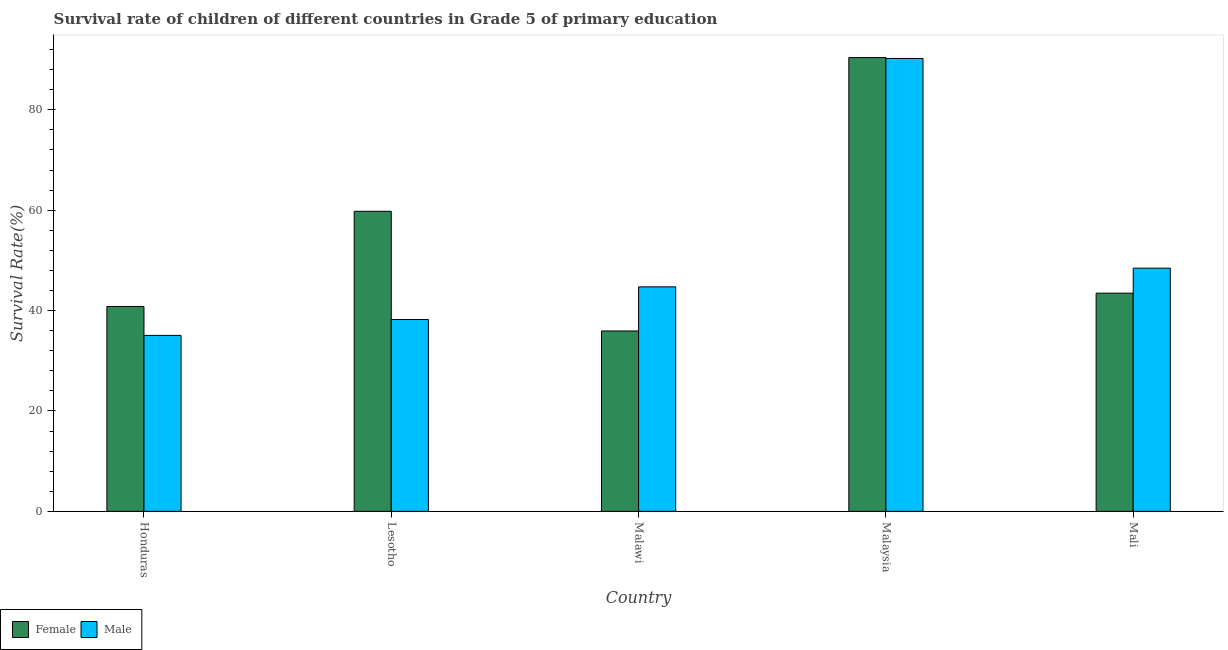How many different coloured bars are there?
Keep it short and to the point. 2. How many bars are there on the 4th tick from the left?
Your answer should be very brief. 2. How many bars are there on the 3rd tick from the right?
Your response must be concise. 2. What is the label of the 4th group of bars from the left?
Your answer should be very brief. Malaysia. What is the survival rate of male students in primary education in Lesotho?
Offer a terse response. 38.23. Across all countries, what is the maximum survival rate of male students in primary education?
Your response must be concise. 90.23. Across all countries, what is the minimum survival rate of female students in primary education?
Offer a very short reply. 35.94. In which country was the survival rate of female students in primary education maximum?
Give a very brief answer. Malaysia. In which country was the survival rate of male students in primary education minimum?
Your answer should be very brief. Honduras. What is the total survival rate of female students in primary education in the graph?
Provide a succinct answer. 270.44. What is the difference between the survival rate of male students in primary education in Malawi and that in Mali?
Provide a short and direct response. -3.72. What is the difference between the survival rate of female students in primary education in Malaysia and the survival rate of male students in primary education in Mali?
Your response must be concise. 41.96. What is the average survival rate of male students in primary education per country?
Ensure brevity in your answer.  51.34. What is the difference between the survival rate of female students in primary education and survival rate of male students in primary education in Lesotho?
Keep it short and to the point. 21.56. What is the ratio of the survival rate of male students in primary education in Honduras to that in Malawi?
Your answer should be very brief. 0.78. Is the survival rate of female students in primary education in Honduras less than that in Malaysia?
Make the answer very short. Yes. What is the difference between the highest and the second highest survival rate of male students in primary education?
Your response must be concise. 41.78. What is the difference between the highest and the lowest survival rate of male students in primary education?
Your answer should be compact. 55.17. What does the 2nd bar from the left in Honduras represents?
Provide a short and direct response. Male. How many bars are there?
Your response must be concise. 10. Are all the bars in the graph horizontal?
Your answer should be compact. No. What is the difference between two consecutive major ticks on the Y-axis?
Your response must be concise. 20. Does the graph contain any zero values?
Provide a short and direct response. No. Does the graph contain grids?
Offer a terse response. No. Where does the legend appear in the graph?
Your answer should be compact. Bottom left. What is the title of the graph?
Offer a very short reply. Survival rate of children of different countries in Grade 5 of primary education. What is the label or title of the X-axis?
Your answer should be compact. Country. What is the label or title of the Y-axis?
Keep it short and to the point. Survival Rate(%). What is the Survival Rate(%) in Female in Honduras?
Provide a short and direct response. 40.82. What is the Survival Rate(%) of Male in Honduras?
Give a very brief answer. 35.06. What is the Survival Rate(%) of Female in Lesotho?
Ensure brevity in your answer.  59.79. What is the Survival Rate(%) of Male in Lesotho?
Offer a terse response. 38.23. What is the Survival Rate(%) of Female in Malawi?
Offer a very short reply. 35.94. What is the Survival Rate(%) in Male in Malawi?
Offer a terse response. 44.73. What is the Survival Rate(%) in Female in Malaysia?
Provide a short and direct response. 90.42. What is the Survival Rate(%) of Male in Malaysia?
Ensure brevity in your answer.  90.23. What is the Survival Rate(%) of Female in Mali?
Provide a succinct answer. 43.48. What is the Survival Rate(%) of Male in Mali?
Make the answer very short. 48.46. Across all countries, what is the maximum Survival Rate(%) in Female?
Your answer should be very brief. 90.42. Across all countries, what is the maximum Survival Rate(%) of Male?
Your response must be concise. 90.23. Across all countries, what is the minimum Survival Rate(%) in Female?
Your answer should be compact. 35.94. Across all countries, what is the minimum Survival Rate(%) in Male?
Provide a short and direct response. 35.06. What is the total Survival Rate(%) in Female in the graph?
Your answer should be very brief. 270.44. What is the total Survival Rate(%) in Male in the graph?
Provide a short and direct response. 256.71. What is the difference between the Survival Rate(%) in Female in Honduras and that in Lesotho?
Offer a terse response. -18.96. What is the difference between the Survival Rate(%) in Male in Honduras and that in Lesotho?
Keep it short and to the point. -3.17. What is the difference between the Survival Rate(%) of Female in Honduras and that in Malawi?
Provide a short and direct response. 4.88. What is the difference between the Survival Rate(%) in Male in Honduras and that in Malawi?
Make the answer very short. -9.67. What is the difference between the Survival Rate(%) in Female in Honduras and that in Malaysia?
Your response must be concise. -49.59. What is the difference between the Survival Rate(%) in Male in Honduras and that in Malaysia?
Keep it short and to the point. -55.17. What is the difference between the Survival Rate(%) of Female in Honduras and that in Mali?
Provide a short and direct response. -2.65. What is the difference between the Survival Rate(%) of Male in Honduras and that in Mali?
Ensure brevity in your answer.  -13.4. What is the difference between the Survival Rate(%) of Female in Lesotho and that in Malawi?
Offer a terse response. 23.84. What is the difference between the Survival Rate(%) of Male in Lesotho and that in Malawi?
Give a very brief answer. -6.5. What is the difference between the Survival Rate(%) in Female in Lesotho and that in Malaysia?
Your answer should be very brief. -30.63. What is the difference between the Survival Rate(%) of Male in Lesotho and that in Malaysia?
Your answer should be compact. -52. What is the difference between the Survival Rate(%) of Female in Lesotho and that in Mali?
Ensure brevity in your answer.  16.31. What is the difference between the Survival Rate(%) in Male in Lesotho and that in Mali?
Offer a terse response. -10.23. What is the difference between the Survival Rate(%) of Female in Malawi and that in Malaysia?
Keep it short and to the point. -54.47. What is the difference between the Survival Rate(%) of Male in Malawi and that in Malaysia?
Provide a succinct answer. -45.5. What is the difference between the Survival Rate(%) of Female in Malawi and that in Mali?
Your answer should be compact. -7.54. What is the difference between the Survival Rate(%) in Male in Malawi and that in Mali?
Your response must be concise. -3.72. What is the difference between the Survival Rate(%) of Female in Malaysia and that in Mali?
Keep it short and to the point. 46.94. What is the difference between the Survival Rate(%) in Male in Malaysia and that in Mali?
Offer a very short reply. 41.78. What is the difference between the Survival Rate(%) in Female in Honduras and the Survival Rate(%) in Male in Lesotho?
Offer a very short reply. 2.6. What is the difference between the Survival Rate(%) of Female in Honduras and the Survival Rate(%) of Male in Malawi?
Keep it short and to the point. -3.91. What is the difference between the Survival Rate(%) of Female in Honduras and the Survival Rate(%) of Male in Malaysia?
Provide a short and direct response. -49.41. What is the difference between the Survival Rate(%) in Female in Honduras and the Survival Rate(%) in Male in Mali?
Your answer should be very brief. -7.63. What is the difference between the Survival Rate(%) in Female in Lesotho and the Survival Rate(%) in Male in Malawi?
Provide a succinct answer. 15.05. What is the difference between the Survival Rate(%) in Female in Lesotho and the Survival Rate(%) in Male in Malaysia?
Provide a short and direct response. -30.45. What is the difference between the Survival Rate(%) of Female in Lesotho and the Survival Rate(%) of Male in Mali?
Offer a very short reply. 11.33. What is the difference between the Survival Rate(%) of Female in Malawi and the Survival Rate(%) of Male in Malaysia?
Your response must be concise. -54.29. What is the difference between the Survival Rate(%) in Female in Malawi and the Survival Rate(%) in Male in Mali?
Ensure brevity in your answer.  -12.51. What is the difference between the Survival Rate(%) of Female in Malaysia and the Survival Rate(%) of Male in Mali?
Keep it short and to the point. 41.96. What is the average Survival Rate(%) in Female per country?
Provide a short and direct response. 54.09. What is the average Survival Rate(%) in Male per country?
Ensure brevity in your answer.  51.34. What is the difference between the Survival Rate(%) of Female and Survival Rate(%) of Male in Honduras?
Provide a short and direct response. 5.76. What is the difference between the Survival Rate(%) of Female and Survival Rate(%) of Male in Lesotho?
Ensure brevity in your answer.  21.56. What is the difference between the Survival Rate(%) in Female and Survival Rate(%) in Male in Malawi?
Offer a very short reply. -8.79. What is the difference between the Survival Rate(%) in Female and Survival Rate(%) in Male in Malaysia?
Your response must be concise. 0.18. What is the difference between the Survival Rate(%) of Female and Survival Rate(%) of Male in Mali?
Give a very brief answer. -4.98. What is the ratio of the Survival Rate(%) in Female in Honduras to that in Lesotho?
Offer a very short reply. 0.68. What is the ratio of the Survival Rate(%) of Male in Honduras to that in Lesotho?
Ensure brevity in your answer.  0.92. What is the ratio of the Survival Rate(%) of Female in Honduras to that in Malawi?
Provide a succinct answer. 1.14. What is the ratio of the Survival Rate(%) in Male in Honduras to that in Malawi?
Offer a very short reply. 0.78. What is the ratio of the Survival Rate(%) of Female in Honduras to that in Malaysia?
Ensure brevity in your answer.  0.45. What is the ratio of the Survival Rate(%) of Male in Honduras to that in Malaysia?
Offer a terse response. 0.39. What is the ratio of the Survival Rate(%) in Female in Honduras to that in Mali?
Offer a very short reply. 0.94. What is the ratio of the Survival Rate(%) in Male in Honduras to that in Mali?
Make the answer very short. 0.72. What is the ratio of the Survival Rate(%) in Female in Lesotho to that in Malawi?
Make the answer very short. 1.66. What is the ratio of the Survival Rate(%) of Male in Lesotho to that in Malawi?
Keep it short and to the point. 0.85. What is the ratio of the Survival Rate(%) of Female in Lesotho to that in Malaysia?
Make the answer very short. 0.66. What is the ratio of the Survival Rate(%) in Male in Lesotho to that in Malaysia?
Offer a very short reply. 0.42. What is the ratio of the Survival Rate(%) of Female in Lesotho to that in Mali?
Keep it short and to the point. 1.38. What is the ratio of the Survival Rate(%) in Male in Lesotho to that in Mali?
Keep it short and to the point. 0.79. What is the ratio of the Survival Rate(%) of Female in Malawi to that in Malaysia?
Ensure brevity in your answer.  0.4. What is the ratio of the Survival Rate(%) of Male in Malawi to that in Malaysia?
Your answer should be very brief. 0.5. What is the ratio of the Survival Rate(%) of Female in Malawi to that in Mali?
Your answer should be compact. 0.83. What is the ratio of the Survival Rate(%) of Male in Malawi to that in Mali?
Offer a terse response. 0.92. What is the ratio of the Survival Rate(%) in Female in Malaysia to that in Mali?
Make the answer very short. 2.08. What is the ratio of the Survival Rate(%) in Male in Malaysia to that in Mali?
Give a very brief answer. 1.86. What is the difference between the highest and the second highest Survival Rate(%) of Female?
Offer a terse response. 30.63. What is the difference between the highest and the second highest Survival Rate(%) of Male?
Give a very brief answer. 41.78. What is the difference between the highest and the lowest Survival Rate(%) of Female?
Offer a very short reply. 54.47. What is the difference between the highest and the lowest Survival Rate(%) in Male?
Provide a succinct answer. 55.17. 